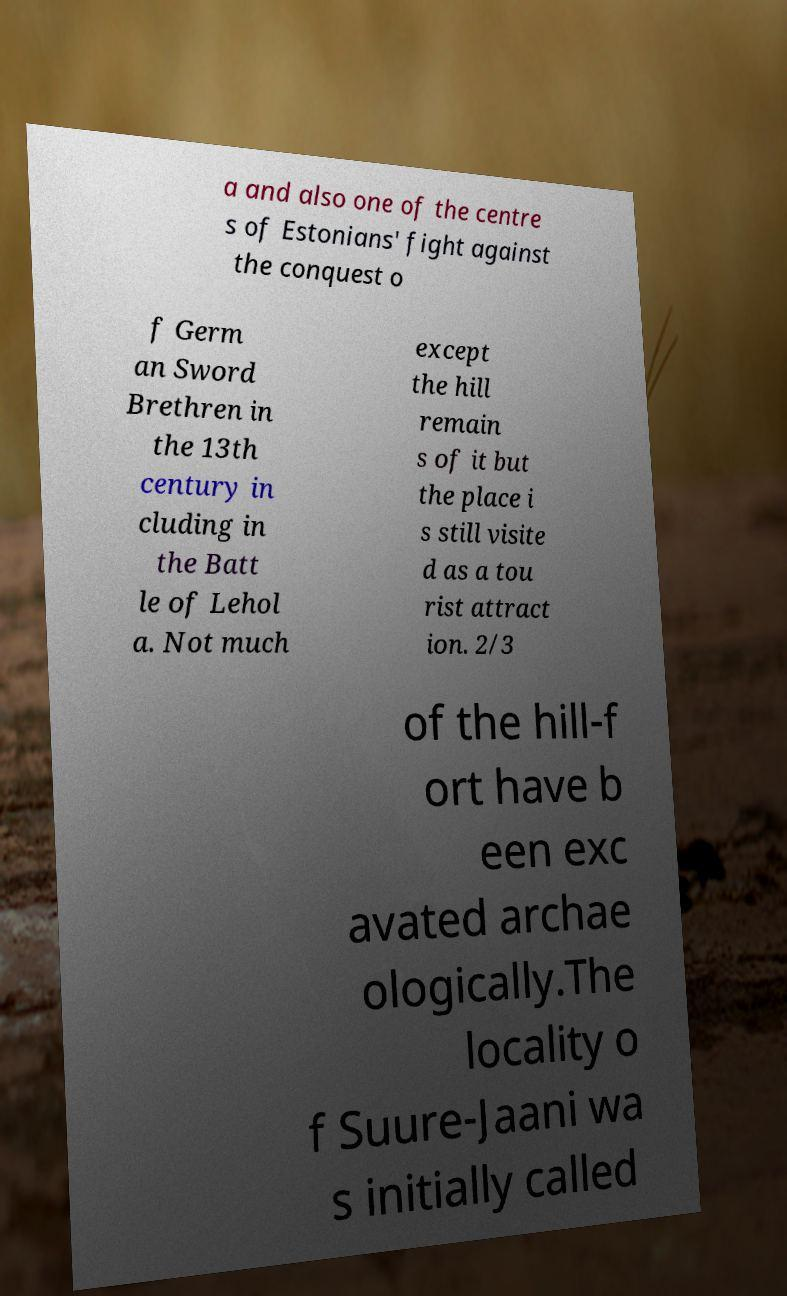For documentation purposes, I need the text within this image transcribed. Could you provide that? a and also one of the centre s of Estonians' fight against the conquest o f Germ an Sword Brethren in the 13th century in cluding in the Batt le of Lehol a. Not much except the hill remain s of it but the place i s still visite d as a tou rist attract ion. 2/3 of the hill-f ort have b een exc avated archae ologically.The locality o f Suure-Jaani wa s initially called 